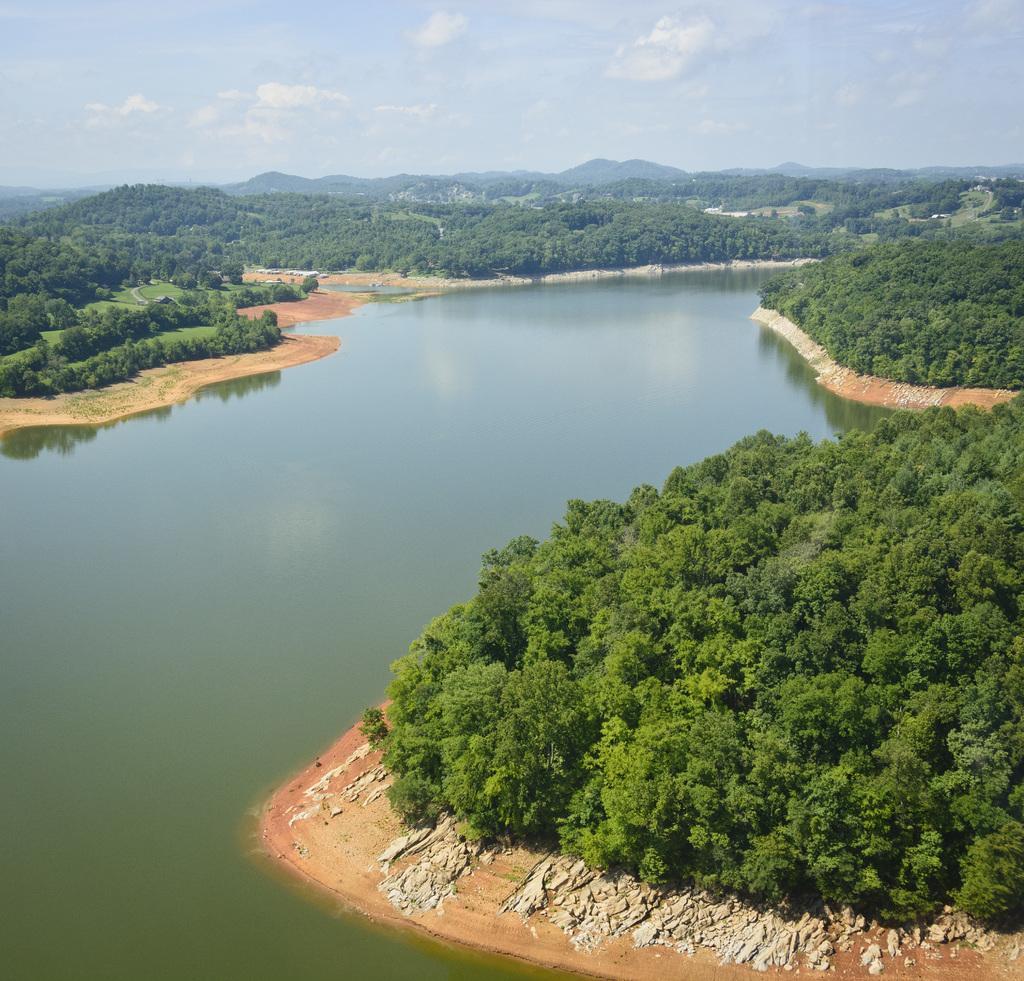Please provide a concise description of this image. In this image, we can see water, trees and stones. At the top of the image, we can see the hills and cloudy sky. 